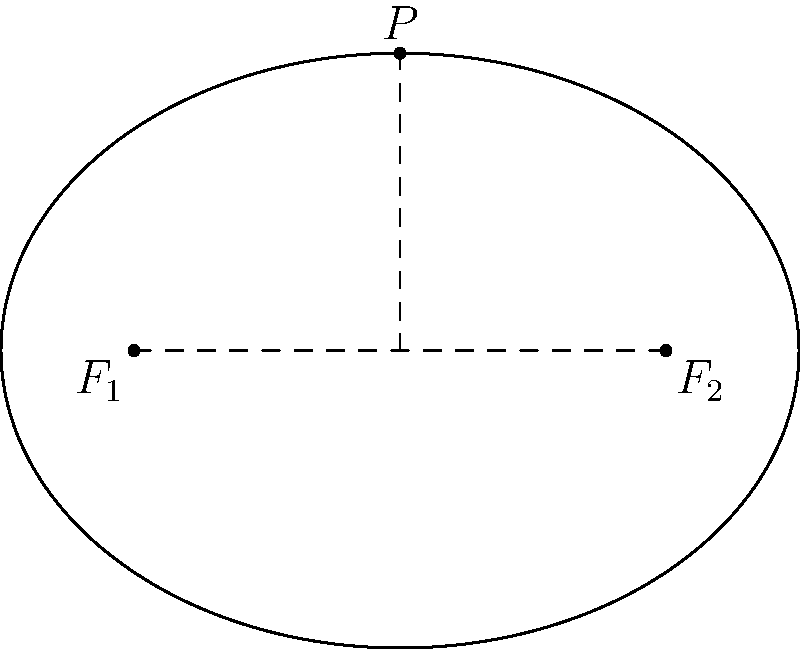An ellipse represents the balance between personal beliefs ($F_1$) and religious teachings ($F_2$). If the distance between the foci is 4 units and the length of the semi-major axis is 3 units, what is the eccentricity of the ellipse? How might this relate to the couple's alignment of beliefs? To find the eccentricity of the ellipse, we'll follow these steps:

1) The eccentricity ($e$) of an ellipse is given by the formula:

   $$e = \frac{c}{a}$$

   where $c$ is half the distance between the foci, and $a$ is the length of the semi-major axis.

2) We're given that the distance between the foci is 4 units, so $c = 2$ units.

3) We're also given that the length of the semi-major axis is 3 units, so $a = 3$.

4) Substituting these values into the formula:

   $$e = \frac{2}{3} \approx 0.667$$

5) The eccentricity is always between 0 and 1 for an ellipse. A value closer to 0 indicates a more circular shape, while a value closer to 1 indicates a more elongated ellipse.

In the context of the couple's beliefs:
- An eccentricity of $\frac{2}{3}$ suggests a moderate level of tension between personal beliefs and religious teachings.
- If $e$ were closer to 0, it might indicate more alignment between personal beliefs and religious teachings.
- If $e$ were closer to 1, it might suggest greater disparity between personal beliefs and religious obligations.

This metaphorical representation encourages the couple to reflect on how they can work towards a balance that brings their personal beliefs and religious obligations closer together.
Answer: $\frac{2}{3}$ or approximately 0.667 